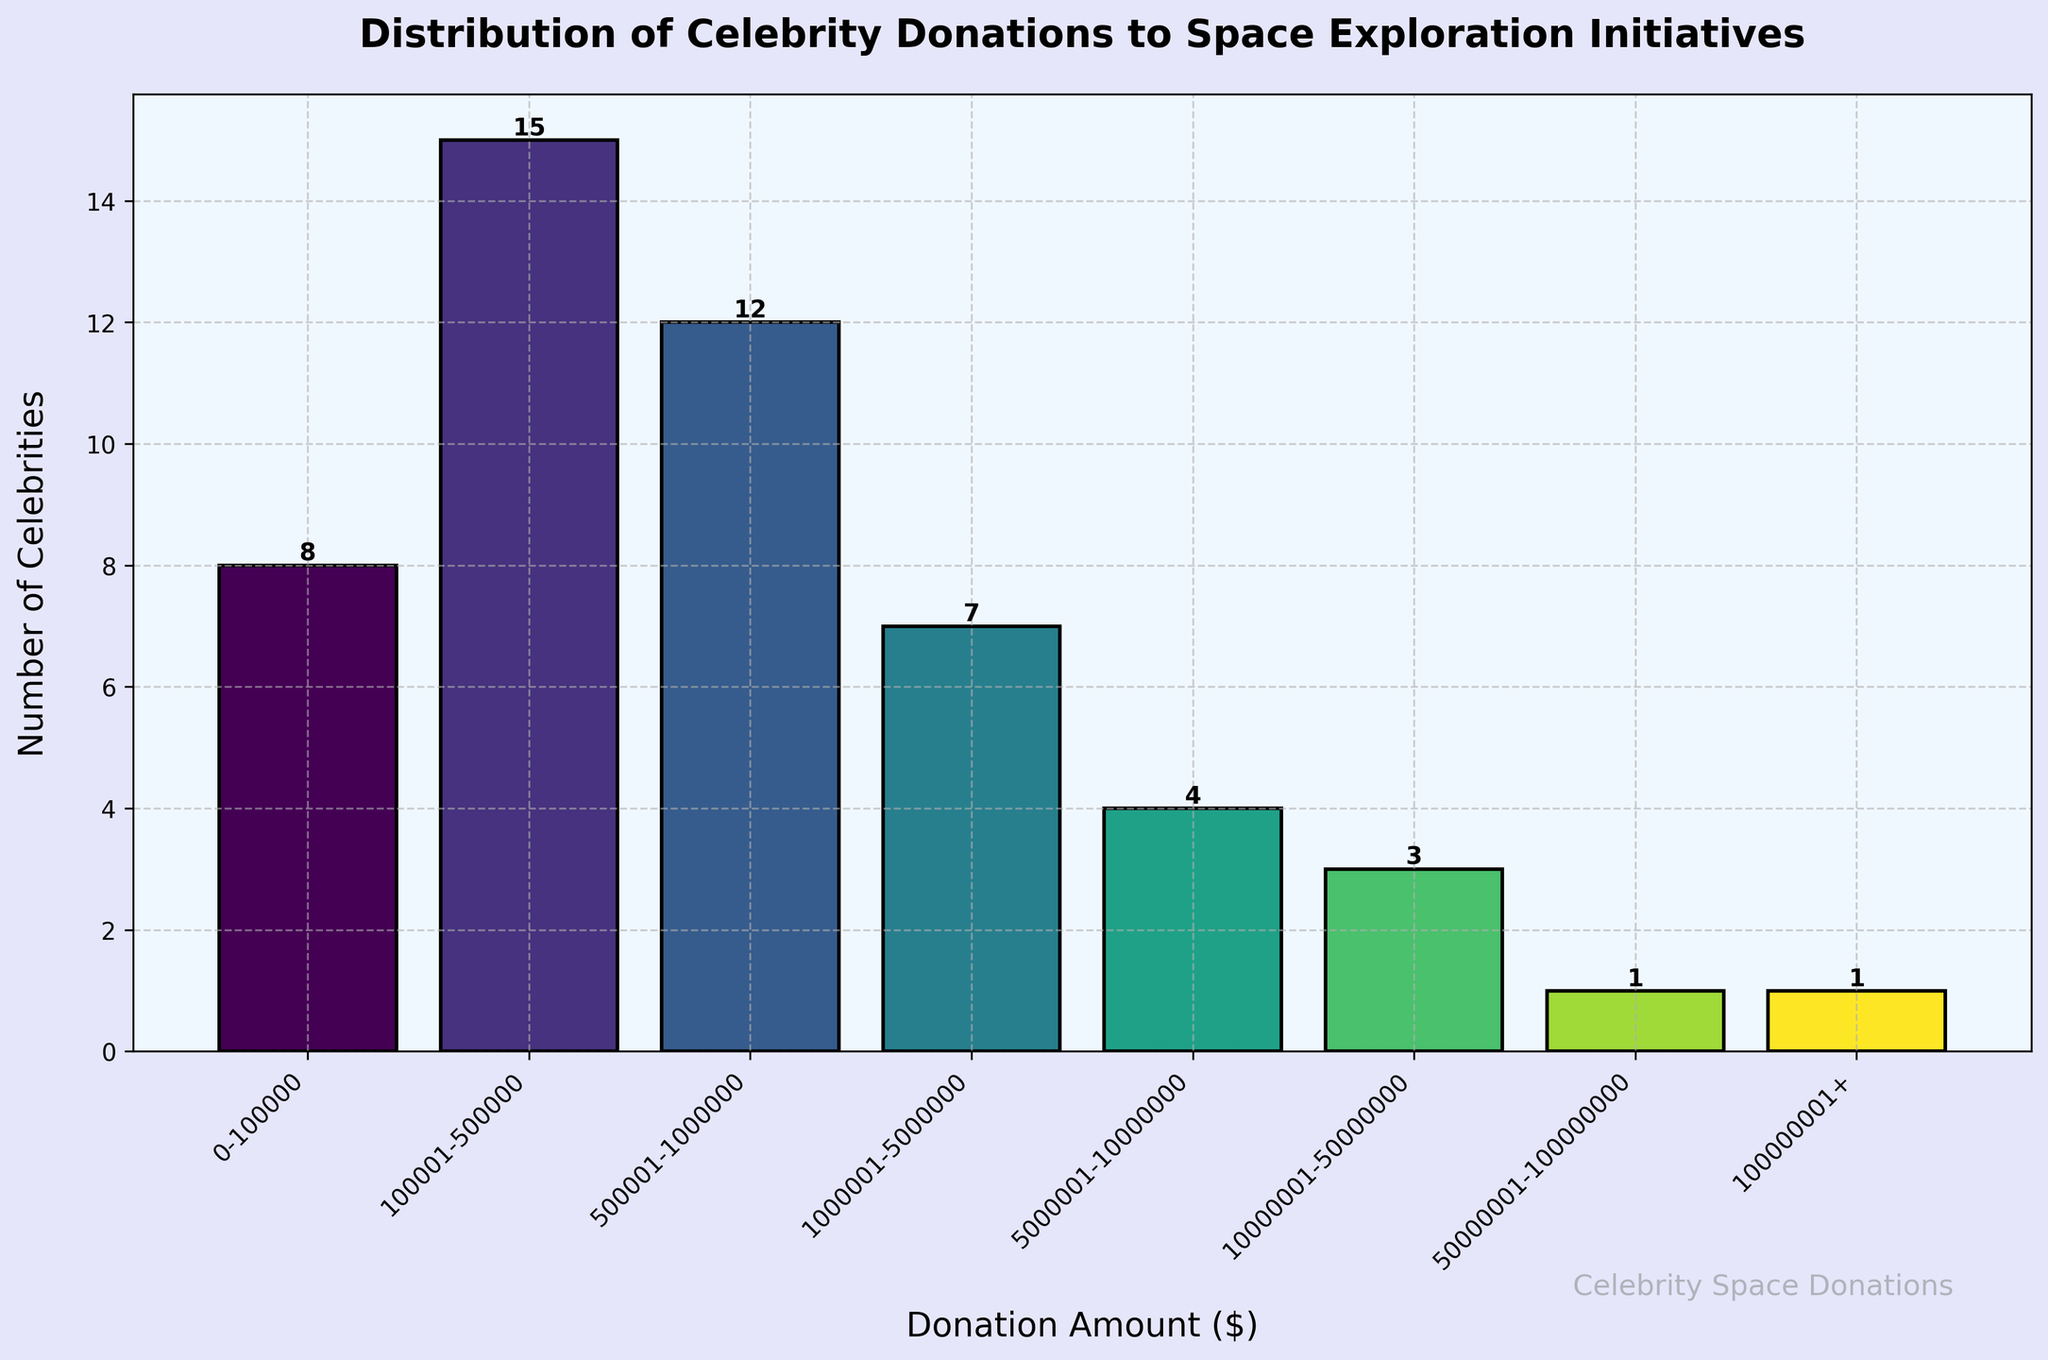What is the title of the histogram? The title of the histogram is at the top of the plot. It is bold and summarizes the data being visualized in the figure.
Answer: Distribution of Celebrity Donations to Space Exploration Initiatives What is the donation range with the highest number of celebrity donations? By looking at the tallest bar in the histogram, we can see that it corresponds to the donation range on the x-axis with the highest count on the y-axis.
Answer: 100,001-500,000 How many celebrity donations fall in the $1,000,001 to $5,000,000 range? Locate the bar that represents the $1,000,001 to $5,000,000 range on the x-axis and check the value at the top of the bar, which shows the count. In this case, the bar indicates there are 7 donations.
Answer: 7 Which donation range has only one celebrity donation? Identify the bars with a height of 1 and look at the respective x-axis donation ranges they represent. There are two such bars.
Answer: $50,000,001-$100,000,000 and $100,000,001+ How many more celebrities donated between $100,001 and $500,000 than those who donated between $500,001 and $1,000,000? Find the bars representing each of these ranges. Subtract the count of the $500,001-$1,000,000 range (12) from the count of the $100,001-$500,000 range (15).
Answer: 3 What is the total number of celebrity donations recorded in the histogram? Add the counts of all the bars in the histogram: 8 (0-100,000) + 15 (100,001-500,000) + 12 (500,001-1,000,000) + 7 (1,000,001-5,000,000) + 4 (5,000,001-10,000,000) + 3 (10,000,001-50,000,000) + 1 (50,000,001-100,000,000) + 1 (100,000,001+).
Answer: 51 What is the average number of celebrities per donation range? Sum up all the counts of celebrities and divide by the number of donation ranges (i.e., 8). So, (8 + 15 + 12 + 7 + 4 + 3 + 1 + 1) / 8.
Answer: 6.375 How does the number of donations above $50,000,000 compare to those below $1,000,000? Count the celebrities for donations more than $50,000,000 (1 + 1 = 2) and those for donations under $1,000,000 (8 + 15 + 12 = 35).
Answer: 2 vs. 35 What's the color scheme used for the bars in the histogram? The bars are colored using a gradient from the viridis colormap, which varies from green to yellow. This makes the bars visually appealing and easy to differentiate.
Answer: Green to Yellow 